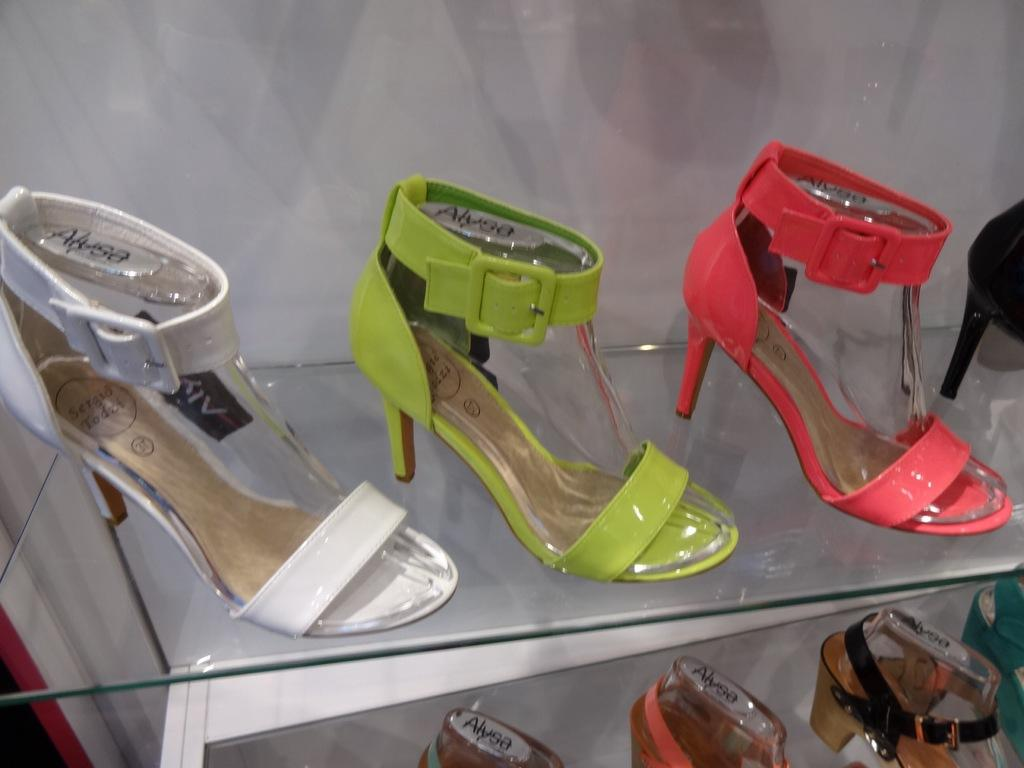<image>
Provide a brief description of the given image. Many different brightly colored Alyssa high heels are displayed on a shelf. 